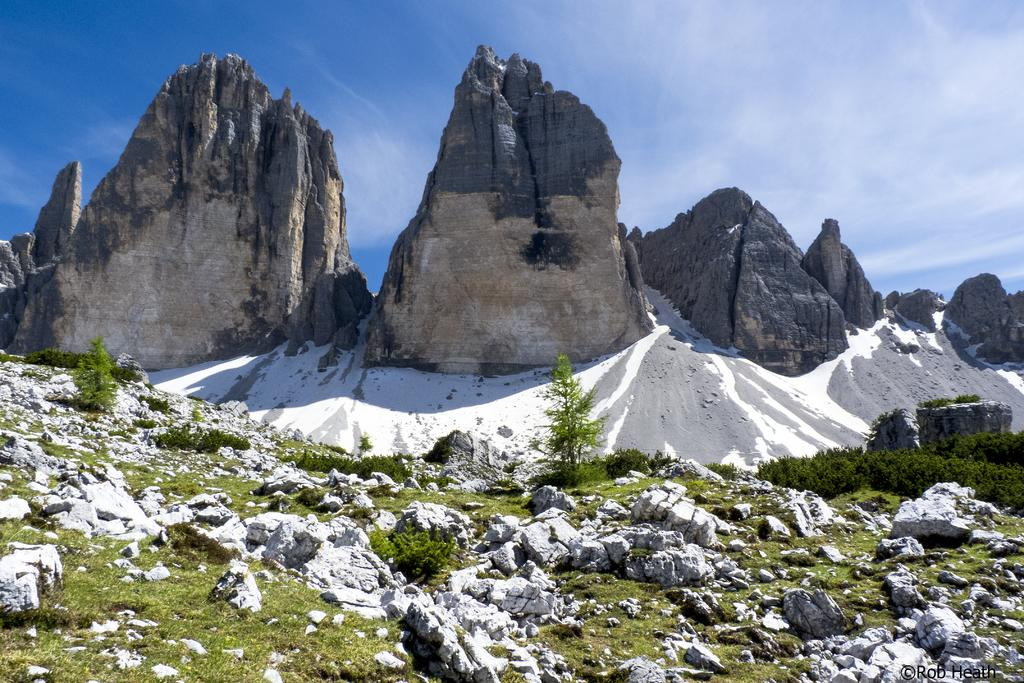What type of natural formation can be seen in the image? There are mountains in the image. What is present on the ground near the mountains? There are rocks on the surface of the grass. What part of the natural environment is visible in the background of the image? The sky is visible in the background of the image. What type of wrench can be seen lying on the grass near the mountains? There is no wrench present in the image; it only features mountains, rocks, and the sky. 